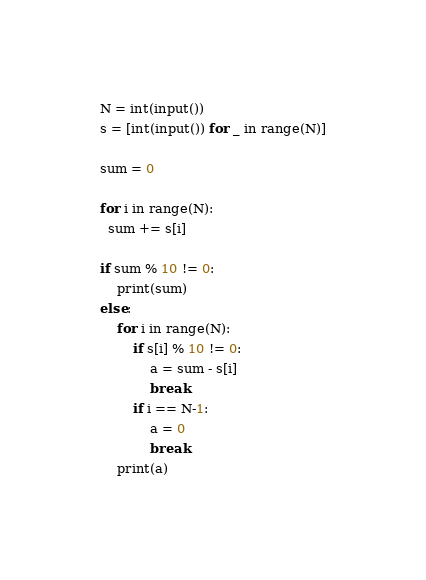Convert code to text. <code><loc_0><loc_0><loc_500><loc_500><_Python_>N = int(input())
s = [int(input()) for _ in range(N)]

sum = 0

for i in range(N):
  sum += s[i]

if sum % 10 != 0:
    print(sum)
else:
    for i in range(N):
        if s[i] % 10 != 0:
            a = sum - s[i]
            break
        if i == N-1:
            a = 0
            break
    print(a)</code> 